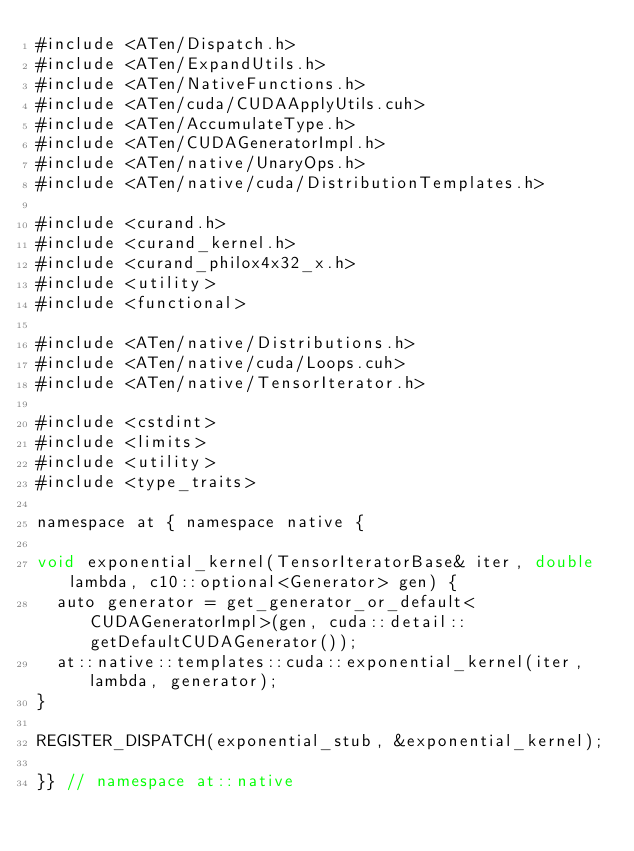<code> <loc_0><loc_0><loc_500><loc_500><_Cuda_>#include <ATen/Dispatch.h>
#include <ATen/ExpandUtils.h>
#include <ATen/NativeFunctions.h>
#include <ATen/cuda/CUDAApplyUtils.cuh>
#include <ATen/AccumulateType.h>
#include <ATen/CUDAGeneratorImpl.h>
#include <ATen/native/UnaryOps.h>
#include <ATen/native/cuda/DistributionTemplates.h>

#include <curand.h>
#include <curand_kernel.h>
#include <curand_philox4x32_x.h>
#include <utility>
#include <functional>

#include <ATen/native/Distributions.h>
#include <ATen/native/cuda/Loops.cuh>
#include <ATen/native/TensorIterator.h>

#include <cstdint>
#include <limits>
#include <utility>
#include <type_traits>

namespace at { namespace native {

void exponential_kernel(TensorIteratorBase& iter, double lambda, c10::optional<Generator> gen) {
  auto generator = get_generator_or_default<CUDAGeneratorImpl>(gen, cuda::detail::getDefaultCUDAGenerator());
  at::native::templates::cuda::exponential_kernel(iter, lambda, generator);
}

REGISTER_DISPATCH(exponential_stub, &exponential_kernel);

}} // namespace at::native
</code> 